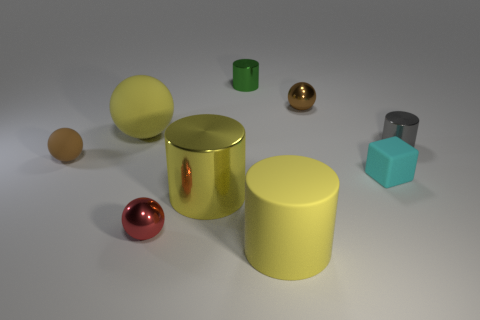Is there any other thing that is the same shape as the tiny cyan object?
Offer a terse response. No. Are there more spheres that are behind the gray metallic cylinder than rubber objects?
Provide a succinct answer. No. Is the number of brown things to the left of the yellow ball less than the number of yellow matte balls?
Offer a terse response. No. What number of big metallic objects are the same color as the large ball?
Offer a very short reply. 1. What is the material of the large yellow object that is in front of the gray object and behind the large yellow matte cylinder?
Provide a succinct answer. Metal. There is a large sphere behind the cyan cube; is its color the same as the shiny ball that is in front of the big rubber sphere?
Give a very brief answer. No. How many red things are either metallic cylinders or tiny cylinders?
Make the answer very short. 0. Is the number of tiny red spheres that are behind the small gray metallic cylinder less than the number of small green metal things that are in front of the green thing?
Offer a terse response. No. Are there any yellow metallic cylinders of the same size as the yellow matte sphere?
Your answer should be very brief. Yes. Do the brown thing in front of the gray object and the tiny cyan block have the same size?
Your answer should be very brief. Yes. 